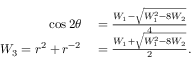<formula> <loc_0><loc_0><loc_500><loc_500>\begin{array} { r l } { \cos 2 \theta } & = \frac { W _ { 1 } - \sqrt { W _ { 1 } ^ { 2 } - 8 W _ { 2 } } } { 4 } } \\ { W _ { 3 } = r ^ { 2 } + r ^ { - 2 } } & = \frac { W _ { 1 } + \sqrt { W _ { 1 } ^ { 2 } - 8 W _ { 2 } } } { 2 } . } \end{array}</formula> 